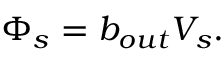<formula> <loc_0><loc_0><loc_500><loc_500>\Phi _ { s } = b _ { o u t } V _ { s } .</formula> 